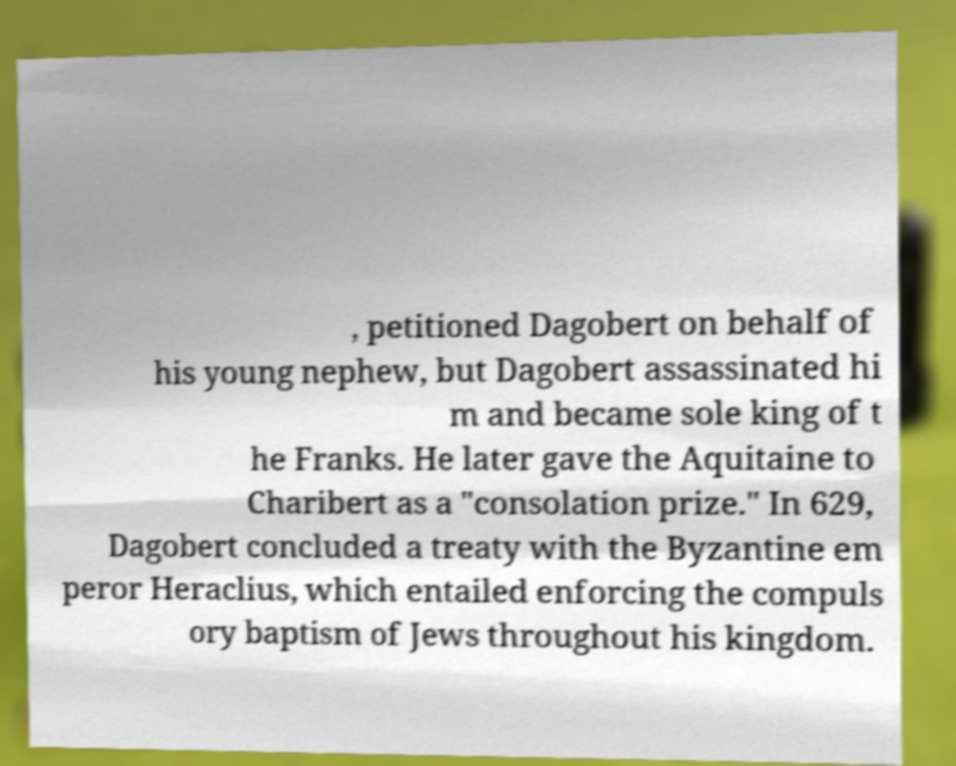Can you read and provide the text displayed in the image?This photo seems to have some interesting text. Can you extract and type it out for me? , petitioned Dagobert on behalf of his young nephew, but Dagobert assassinated hi m and became sole king of t he Franks. He later gave the Aquitaine to Charibert as a "consolation prize." In 629, Dagobert concluded a treaty with the Byzantine em peror Heraclius, which entailed enforcing the compuls ory baptism of Jews throughout his kingdom. 